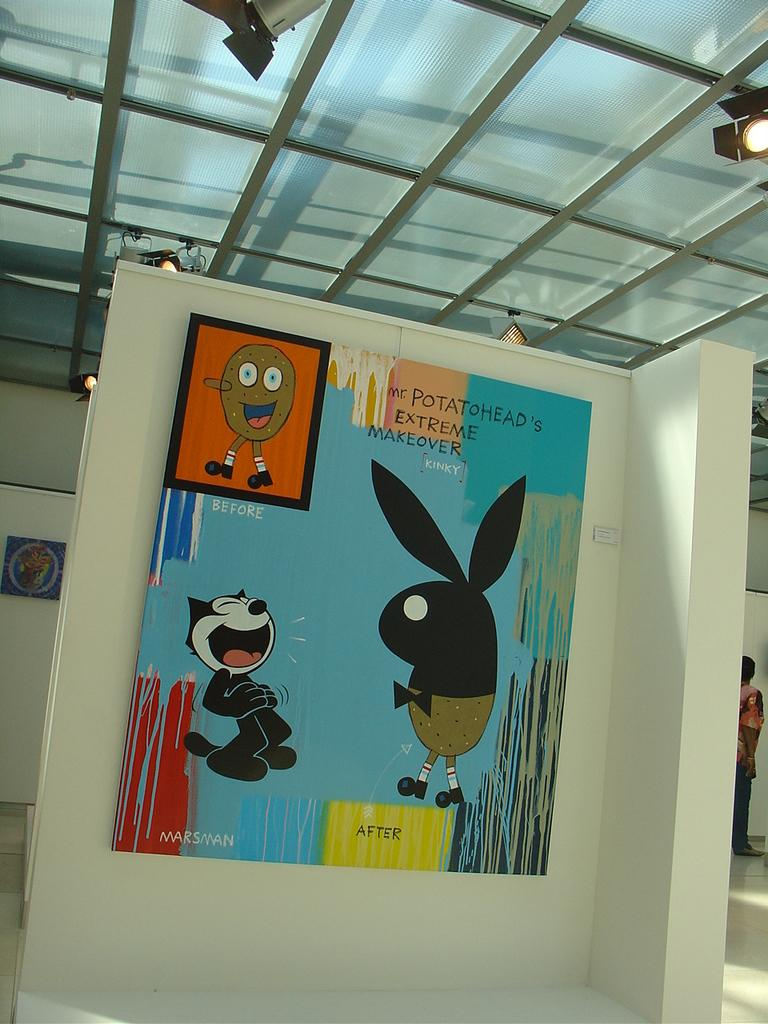What is on the wall in the image? There is a board on a wall in the image. What can be seen on the board? The board contains cartoon images. Can you describe the person in the background of the image? There is a person in the background of the image, but no specific details are provided. What else is on a wall in the background of the image? There is a poster on a wall in the background. What is visible at the top of the image? Lights are visible at the top of the image. What type of receipt can be seen on the board in the image? There is no receipt present on the board in the image; it contains cartoon images. Is there a prison visible in the image? There is no prison present in the image. 